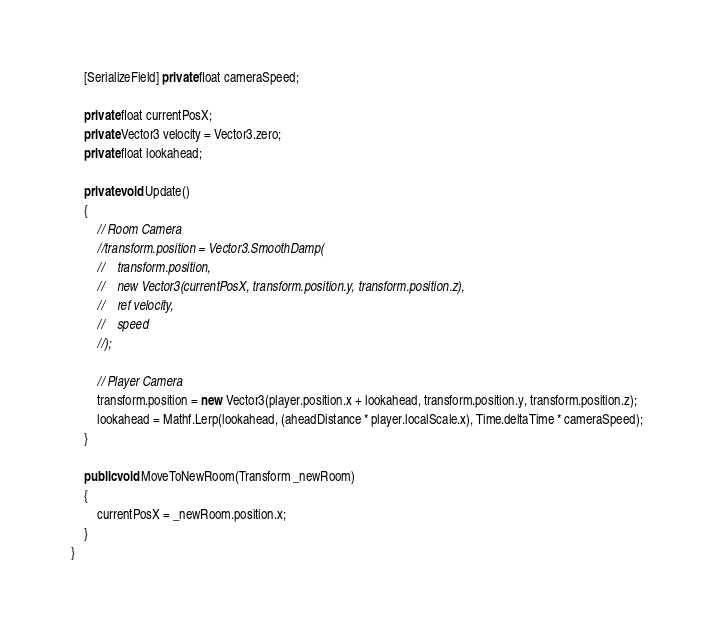<code> <loc_0><loc_0><loc_500><loc_500><_C#_>    [SerializeField] private float cameraSpeed;

    private float currentPosX;
    private Vector3 velocity = Vector3.zero;
    private float lookahead;

    private void Update()
    {
        // Room Camera
        //transform.position = Vector3.SmoothDamp(
        //    transform.position, 
        //    new Vector3(currentPosX, transform.position.y, transform.position.z), 
        //    ref velocity, 
        //    speed
        //);

        // Player Camera
        transform.position = new Vector3(player.position.x + lookahead, transform.position.y, transform.position.z);
        lookahead = Mathf.Lerp(lookahead, (aheadDistance * player.localScale.x), Time.deltaTime * cameraSpeed);
    }

    public void MoveToNewRoom(Transform _newRoom)
    {
        currentPosX = _newRoom.position.x;
    }
}
</code> 